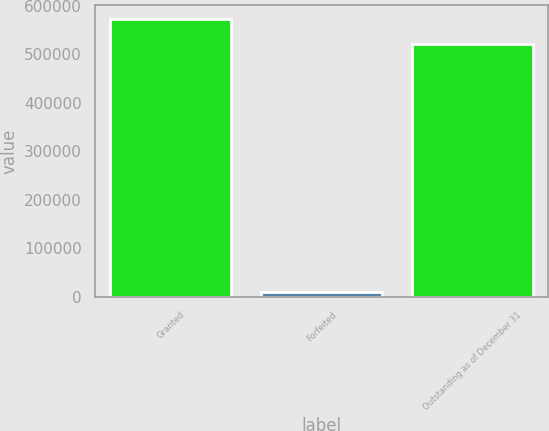Convert chart. <chart><loc_0><loc_0><loc_500><loc_500><bar_chart><fcel>Granted<fcel>Forfeited<fcel>Outstanding as of December 31<nl><fcel>572838<fcel>9222<fcel>520762<nl></chart> 